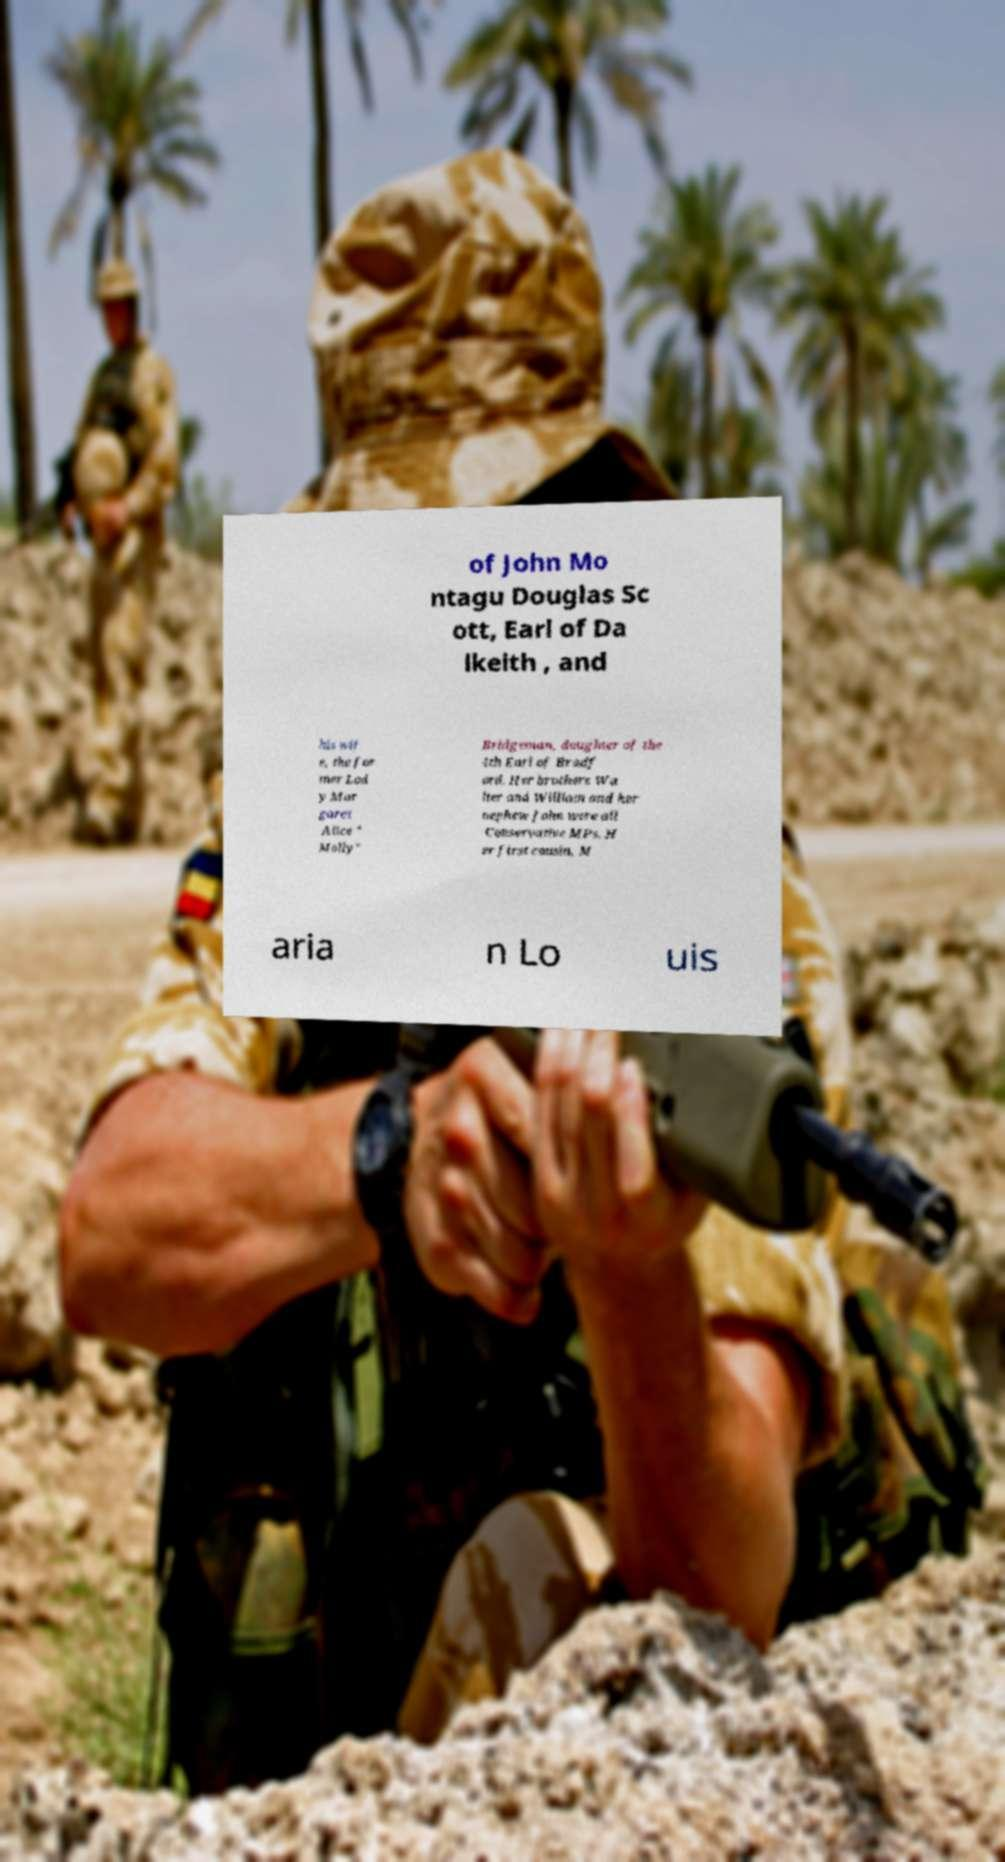For documentation purposes, I need the text within this image transcribed. Could you provide that? of John Mo ntagu Douglas Sc ott, Earl of Da lkeith , and his wif e, the for mer Lad y Mar garet Alice " Molly" Bridgeman, daughter of the 4th Earl of Bradf ord. Her brothers Wa lter and William and her nephew John were all Conservative MPs. H er first cousin, M aria n Lo uis 